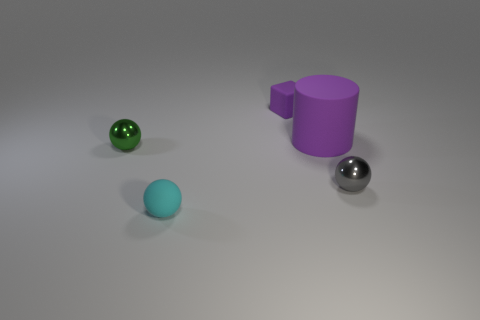Add 3 blue rubber cylinders. How many objects exist? 8 Subtract all cylinders. How many objects are left? 4 Subtract 0 red cylinders. How many objects are left? 5 Subtract all small gray spheres. Subtract all metallic objects. How many objects are left? 2 Add 2 cylinders. How many cylinders are left? 3 Add 4 big green rubber blocks. How many big green rubber blocks exist? 4 